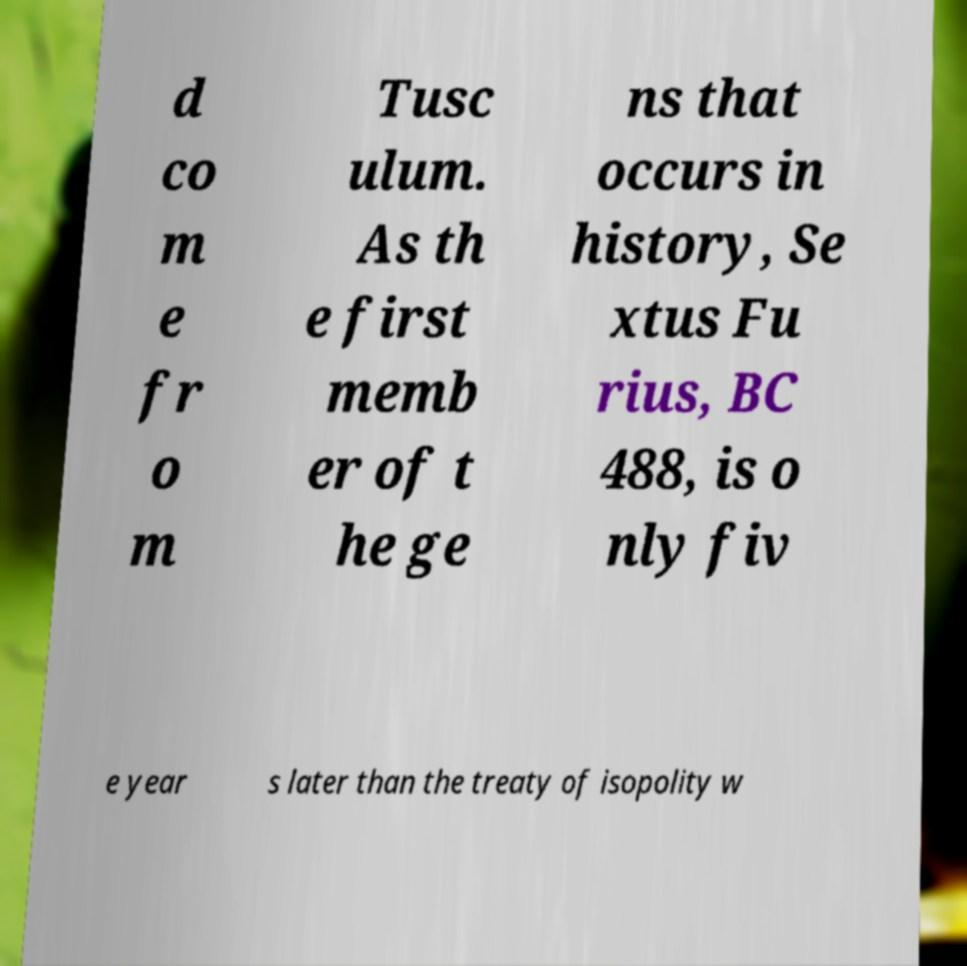Please read and relay the text visible in this image. What does it say? d co m e fr o m Tusc ulum. As th e first memb er of t he ge ns that occurs in history, Se xtus Fu rius, BC 488, is o nly fiv e year s later than the treaty of isopolity w 